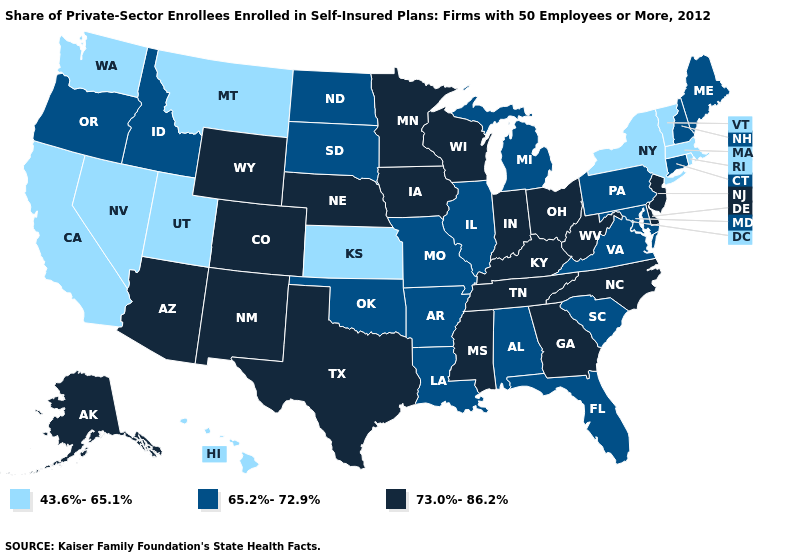Does the first symbol in the legend represent the smallest category?
Be succinct. Yes. Name the states that have a value in the range 65.2%-72.9%?
Answer briefly. Alabama, Arkansas, Connecticut, Florida, Idaho, Illinois, Louisiana, Maine, Maryland, Michigan, Missouri, New Hampshire, North Dakota, Oklahoma, Oregon, Pennsylvania, South Carolina, South Dakota, Virginia. Does the map have missing data?
Be succinct. No. Does Minnesota have the highest value in the MidWest?
Short answer required. Yes. Name the states that have a value in the range 65.2%-72.9%?
Concise answer only. Alabama, Arkansas, Connecticut, Florida, Idaho, Illinois, Louisiana, Maine, Maryland, Michigan, Missouri, New Hampshire, North Dakota, Oklahoma, Oregon, Pennsylvania, South Carolina, South Dakota, Virginia. Does West Virginia have the same value as Tennessee?
Be succinct. Yes. Does Oregon have a lower value than Texas?
Keep it brief. Yes. Does Washington have the lowest value in the West?
Give a very brief answer. Yes. Does Kansas have the lowest value in the MidWest?
Short answer required. Yes. What is the highest value in the USA?
Answer briefly. 73.0%-86.2%. What is the highest value in the West ?
Write a very short answer. 73.0%-86.2%. Which states have the highest value in the USA?
Quick response, please. Alaska, Arizona, Colorado, Delaware, Georgia, Indiana, Iowa, Kentucky, Minnesota, Mississippi, Nebraska, New Jersey, New Mexico, North Carolina, Ohio, Tennessee, Texas, West Virginia, Wisconsin, Wyoming. Does the first symbol in the legend represent the smallest category?
Be succinct. Yes. What is the lowest value in the USA?
Be succinct. 43.6%-65.1%. 